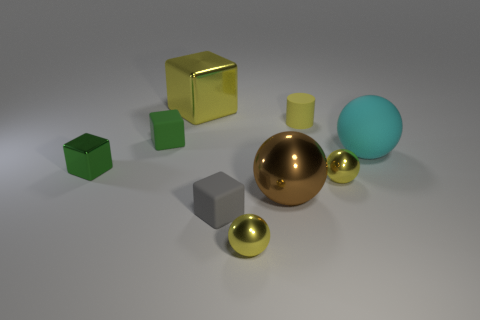There is a rubber sphere; is it the same size as the yellow metal sphere that is to the right of the yellow matte thing?
Your answer should be compact. No. Are there any small balls of the same color as the tiny matte cylinder?
Your answer should be compact. Yes. Is there another gray matte object of the same shape as the tiny gray rubber object?
Make the answer very short. No. What is the shape of the shiny thing that is both in front of the large yellow metal thing and left of the gray block?
Your response must be concise. Cube. What number of cylinders are made of the same material as the small gray block?
Your answer should be very brief. 1. Is the number of big cyan matte objects in front of the large cyan ball less than the number of small green metallic objects?
Ensure brevity in your answer.  Yes. Is there a large yellow object that is left of the tiny rubber block behind the small gray matte thing?
Your answer should be very brief. No. Is there any other thing that has the same shape as the large yellow object?
Your answer should be compact. Yes. Is the size of the rubber ball the same as the green rubber object?
Provide a short and direct response. No. There is a small thing that is behind the tiny green cube that is on the right side of the green shiny object that is left of the tiny gray matte object; what is it made of?
Keep it short and to the point. Rubber. 